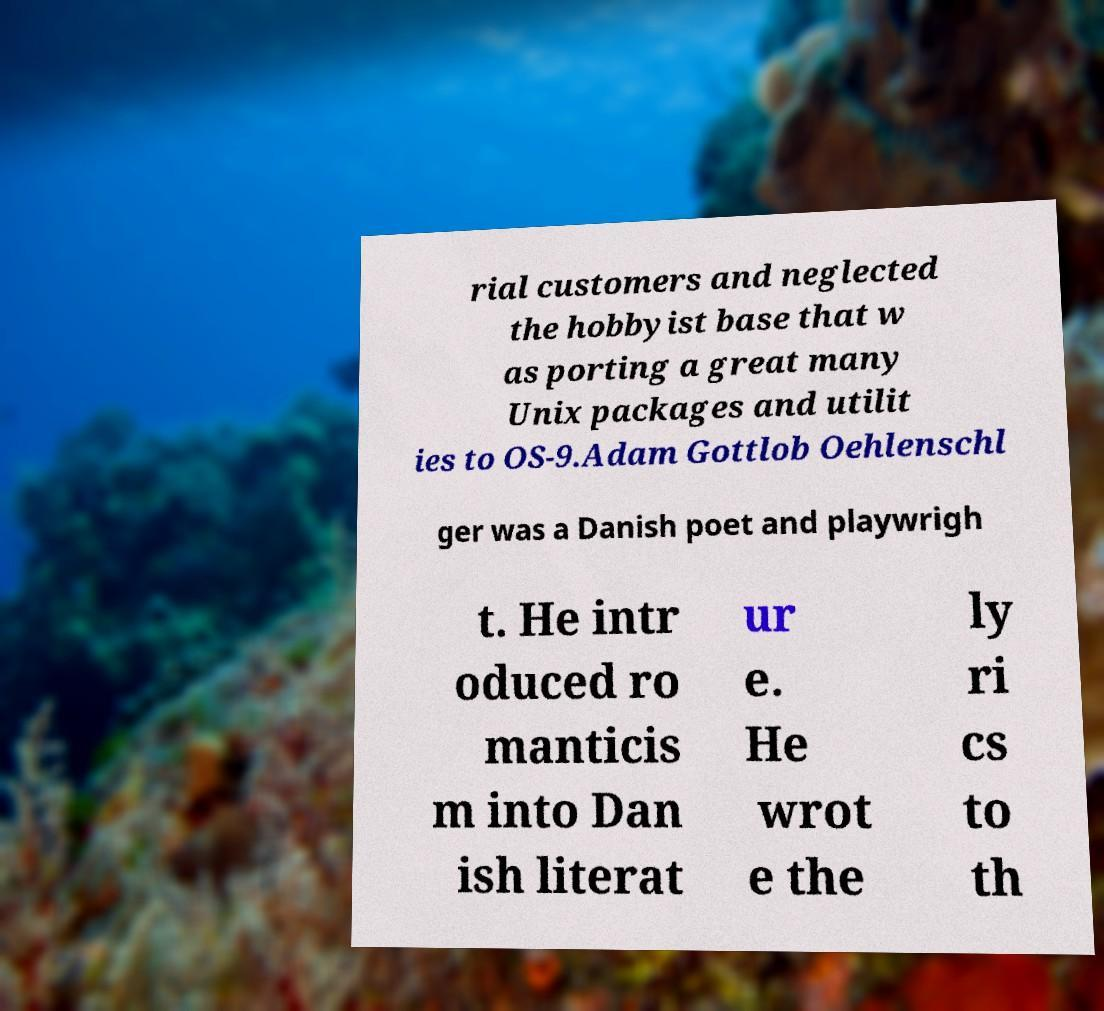There's text embedded in this image that I need extracted. Can you transcribe it verbatim? rial customers and neglected the hobbyist base that w as porting a great many Unix packages and utilit ies to OS-9.Adam Gottlob Oehlenschl ger was a Danish poet and playwrigh t. He intr oduced ro manticis m into Dan ish literat ur e. He wrot e the ly ri cs to th 